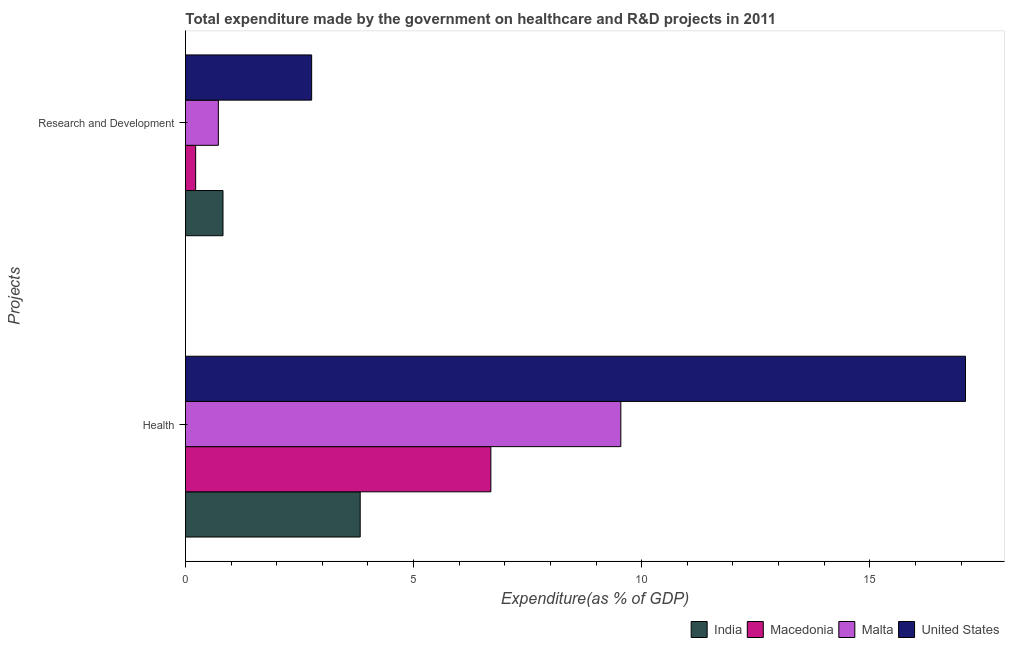Are the number of bars on each tick of the Y-axis equal?
Your response must be concise. Yes. How many bars are there on the 1st tick from the top?
Provide a succinct answer. 4. What is the label of the 1st group of bars from the top?
Offer a very short reply. Research and Development. What is the expenditure in r&d in United States?
Make the answer very short. 2.77. Across all countries, what is the maximum expenditure in r&d?
Give a very brief answer. 2.77. Across all countries, what is the minimum expenditure in r&d?
Your answer should be compact. 0.22. In which country was the expenditure in r&d minimum?
Ensure brevity in your answer.  Macedonia. What is the total expenditure in r&d in the graph?
Provide a succinct answer. 4.53. What is the difference between the expenditure in r&d in United States and that in Macedonia?
Offer a terse response. 2.54. What is the difference between the expenditure in r&d in United States and the expenditure in healthcare in India?
Offer a very short reply. -1.06. What is the average expenditure in r&d per country?
Make the answer very short. 1.13. What is the difference between the expenditure in r&d and expenditure in healthcare in Macedonia?
Provide a short and direct response. -6.47. In how many countries, is the expenditure in r&d greater than 12 %?
Offer a terse response. 0. What is the ratio of the expenditure in healthcare in Malta to that in India?
Provide a succinct answer. 2.49. What does the 4th bar from the bottom in Health represents?
Offer a very short reply. United States. How many countries are there in the graph?
Your answer should be very brief. 4. Are the values on the major ticks of X-axis written in scientific E-notation?
Offer a very short reply. No. Does the graph contain any zero values?
Make the answer very short. No. Does the graph contain grids?
Keep it short and to the point. No. Where does the legend appear in the graph?
Give a very brief answer. Bottom right. How are the legend labels stacked?
Offer a very short reply. Horizontal. What is the title of the graph?
Offer a terse response. Total expenditure made by the government on healthcare and R&D projects in 2011. Does "Sub-Saharan Africa (all income levels)" appear as one of the legend labels in the graph?
Your answer should be very brief. No. What is the label or title of the X-axis?
Your response must be concise. Expenditure(as % of GDP). What is the label or title of the Y-axis?
Give a very brief answer. Projects. What is the Expenditure(as % of GDP) of India in Health?
Give a very brief answer. 3.83. What is the Expenditure(as % of GDP) in Macedonia in Health?
Provide a succinct answer. 6.69. What is the Expenditure(as % of GDP) in Malta in Health?
Keep it short and to the point. 9.54. What is the Expenditure(as % of GDP) in United States in Health?
Your answer should be very brief. 17.1. What is the Expenditure(as % of GDP) in India in Research and Development?
Keep it short and to the point. 0.82. What is the Expenditure(as % of GDP) in Macedonia in Research and Development?
Your answer should be compact. 0.22. What is the Expenditure(as % of GDP) of Malta in Research and Development?
Offer a terse response. 0.72. What is the Expenditure(as % of GDP) in United States in Research and Development?
Provide a short and direct response. 2.77. Across all Projects, what is the maximum Expenditure(as % of GDP) in India?
Provide a succinct answer. 3.83. Across all Projects, what is the maximum Expenditure(as % of GDP) in Macedonia?
Keep it short and to the point. 6.69. Across all Projects, what is the maximum Expenditure(as % of GDP) in Malta?
Your answer should be compact. 9.54. Across all Projects, what is the maximum Expenditure(as % of GDP) of United States?
Provide a short and direct response. 17.1. Across all Projects, what is the minimum Expenditure(as % of GDP) of India?
Make the answer very short. 0.82. Across all Projects, what is the minimum Expenditure(as % of GDP) in Macedonia?
Ensure brevity in your answer.  0.22. Across all Projects, what is the minimum Expenditure(as % of GDP) of Malta?
Give a very brief answer. 0.72. Across all Projects, what is the minimum Expenditure(as % of GDP) in United States?
Your response must be concise. 2.77. What is the total Expenditure(as % of GDP) in India in the graph?
Your response must be concise. 4.65. What is the total Expenditure(as % of GDP) in Macedonia in the graph?
Ensure brevity in your answer.  6.92. What is the total Expenditure(as % of GDP) in Malta in the graph?
Offer a very short reply. 10.26. What is the total Expenditure(as % of GDP) in United States in the graph?
Provide a short and direct response. 19.86. What is the difference between the Expenditure(as % of GDP) of India in Health and that in Research and Development?
Your answer should be compact. 3.01. What is the difference between the Expenditure(as % of GDP) of Macedonia in Health and that in Research and Development?
Keep it short and to the point. 6.47. What is the difference between the Expenditure(as % of GDP) in Malta in Health and that in Research and Development?
Give a very brief answer. 8.82. What is the difference between the Expenditure(as % of GDP) of United States in Health and that in Research and Development?
Make the answer very short. 14.33. What is the difference between the Expenditure(as % of GDP) in India in Health and the Expenditure(as % of GDP) in Macedonia in Research and Development?
Keep it short and to the point. 3.61. What is the difference between the Expenditure(as % of GDP) in India in Health and the Expenditure(as % of GDP) in Malta in Research and Development?
Ensure brevity in your answer.  3.11. What is the difference between the Expenditure(as % of GDP) in India in Health and the Expenditure(as % of GDP) in United States in Research and Development?
Your answer should be very brief. 1.06. What is the difference between the Expenditure(as % of GDP) in Macedonia in Health and the Expenditure(as % of GDP) in Malta in Research and Development?
Your response must be concise. 5.97. What is the difference between the Expenditure(as % of GDP) of Macedonia in Health and the Expenditure(as % of GDP) of United States in Research and Development?
Make the answer very short. 3.93. What is the difference between the Expenditure(as % of GDP) of Malta in Health and the Expenditure(as % of GDP) of United States in Research and Development?
Offer a terse response. 6.78. What is the average Expenditure(as % of GDP) of India per Projects?
Offer a terse response. 2.33. What is the average Expenditure(as % of GDP) in Macedonia per Projects?
Ensure brevity in your answer.  3.46. What is the average Expenditure(as % of GDP) of Malta per Projects?
Give a very brief answer. 5.13. What is the average Expenditure(as % of GDP) in United States per Projects?
Ensure brevity in your answer.  9.93. What is the difference between the Expenditure(as % of GDP) in India and Expenditure(as % of GDP) in Macedonia in Health?
Provide a short and direct response. -2.86. What is the difference between the Expenditure(as % of GDP) of India and Expenditure(as % of GDP) of Malta in Health?
Provide a succinct answer. -5.71. What is the difference between the Expenditure(as % of GDP) of India and Expenditure(as % of GDP) of United States in Health?
Offer a very short reply. -13.27. What is the difference between the Expenditure(as % of GDP) in Macedonia and Expenditure(as % of GDP) in Malta in Health?
Your response must be concise. -2.85. What is the difference between the Expenditure(as % of GDP) of Macedonia and Expenditure(as % of GDP) of United States in Health?
Your response must be concise. -10.4. What is the difference between the Expenditure(as % of GDP) of Malta and Expenditure(as % of GDP) of United States in Health?
Keep it short and to the point. -7.56. What is the difference between the Expenditure(as % of GDP) of India and Expenditure(as % of GDP) of Macedonia in Research and Development?
Provide a succinct answer. 0.6. What is the difference between the Expenditure(as % of GDP) in India and Expenditure(as % of GDP) in Malta in Research and Development?
Give a very brief answer. 0.1. What is the difference between the Expenditure(as % of GDP) in India and Expenditure(as % of GDP) in United States in Research and Development?
Keep it short and to the point. -1.94. What is the difference between the Expenditure(as % of GDP) in Macedonia and Expenditure(as % of GDP) in Malta in Research and Development?
Your answer should be very brief. -0.5. What is the difference between the Expenditure(as % of GDP) in Macedonia and Expenditure(as % of GDP) in United States in Research and Development?
Provide a short and direct response. -2.54. What is the difference between the Expenditure(as % of GDP) in Malta and Expenditure(as % of GDP) in United States in Research and Development?
Your response must be concise. -2.04. What is the ratio of the Expenditure(as % of GDP) of India in Health to that in Research and Development?
Make the answer very short. 4.66. What is the ratio of the Expenditure(as % of GDP) in Macedonia in Health to that in Research and Development?
Your answer should be compact. 30.05. What is the ratio of the Expenditure(as % of GDP) of Malta in Health to that in Research and Development?
Keep it short and to the point. 13.24. What is the ratio of the Expenditure(as % of GDP) in United States in Health to that in Research and Development?
Your answer should be very brief. 6.18. What is the difference between the highest and the second highest Expenditure(as % of GDP) of India?
Your response must be concise. 3.01. What is the difference between the highest and the second highest Expenditure(as % of GDP) of Macedonia?
Your answer should be compact. 6.47. What is the difference between the highest and the second highest Expenditure(as % of GDP) of Malta?
Provide a succinct answer. 8.82. What is the difference between the highest and the second highest Expenditure(as % of GDP) of United States?
Provide a succinct answer. 14.33. What is the difference between the highest and the lowest Expenditure(as % of GDP) of India?
Give a very brief answer. 3.01. What is the difference between the highest and the lowest Expenditure(as % of GDP) of Macedonia?
Make the answer very short. 6.47. What is the difference between the highest and the lowest Expenditure(as % of GDP) in Malta?
Offer a terse response. 8.82. What is the difference between the highest and the lowest Expenditure(as % of GDP) of United States?
Make the answer very short. 14.33. 